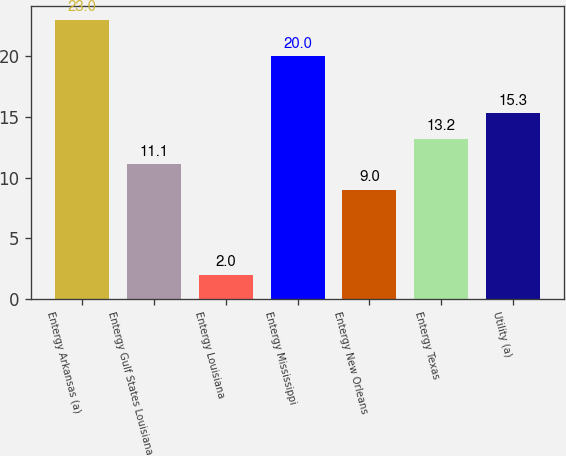Convert chart. <chart><loc_0><loc_0><loc_500><loc_500><bar_chart><fcel>Entergy Arkansas (a)<fcel>Entergy Gulf States Louisiana<fcel>Entergy Louisiana<fcel>Entergy Mississippi<fcel>Entergy New Orleans<fcel>Entergy Texas<fcel>Utility (a)<nl><fcel>23<fcel>11.1<fcel>2<fcel>20<fcel>9<fcel>13.2<fcel>15.3<nl></chart> 